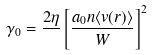Convert formula to latex. <formula><loc_0><loc_0><loc_500><loc_500>\gamma _ { 0 } = \frac { 2 \eta } { } \left [ \frac { a _ { 0 } n \langle v ( r ) \rangle } { W } \right ] ^ { 2 }</formula> 